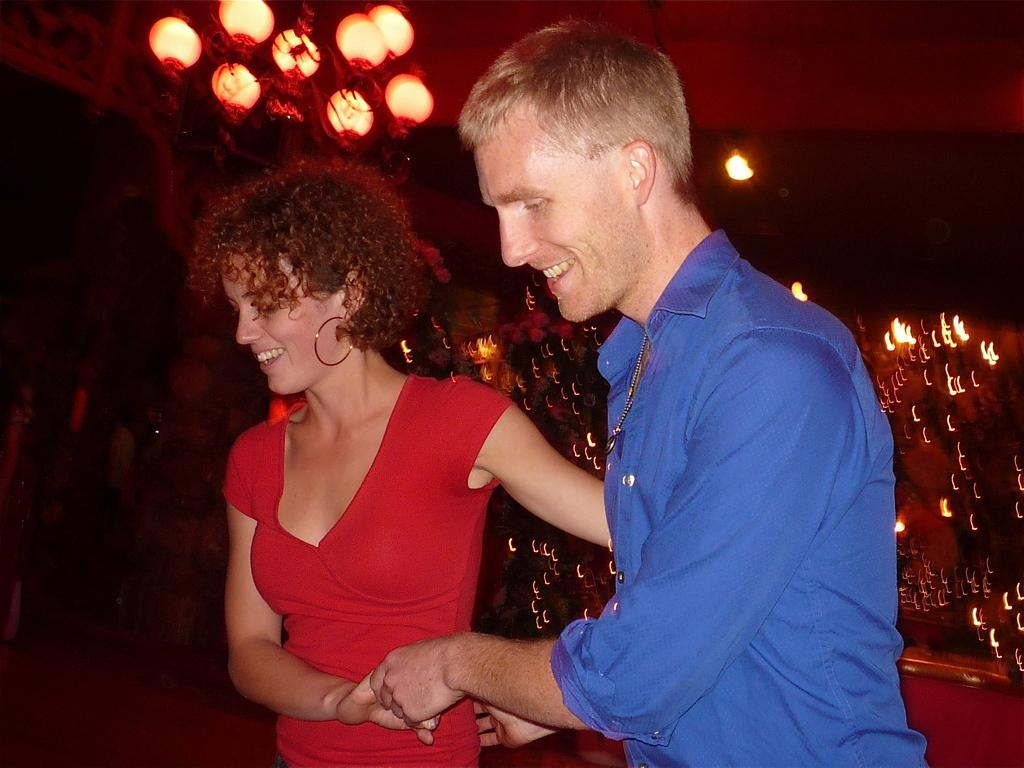How many people are present in the image? There are two people in the image. What are the two people doing in the image? The two people are holding hands. What can be seen in the background of the image? There are beautiful lights visible in the background of the image. What type of hat is the police officer wearing in the image? There is no police officer or hat present in the image. What store can be seen in the background of the image? There is no store visible in the background of the image; only beautiful lights are present. 